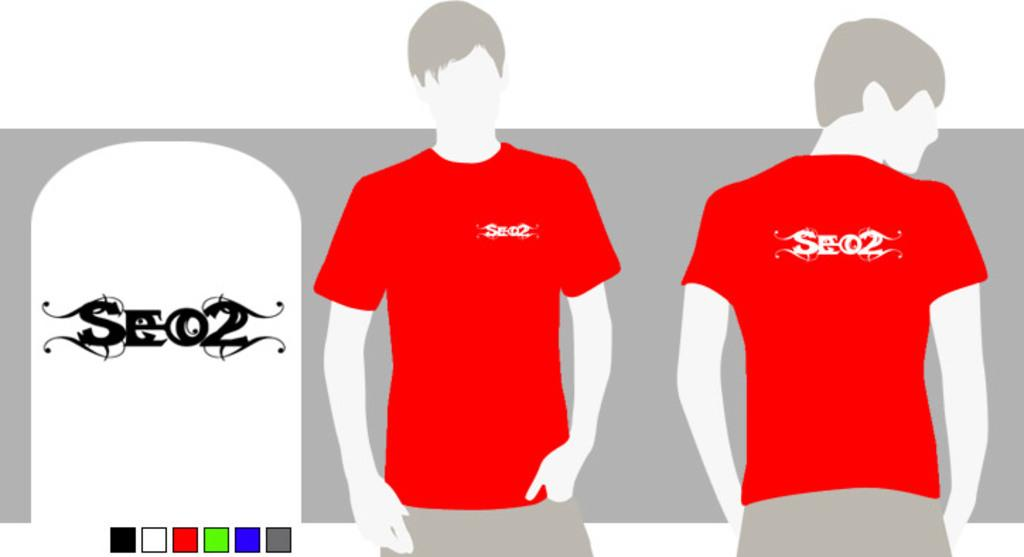<image>
Write a terse but informative summary of the picture. an avatar with SEO2 on the back of their shirt 